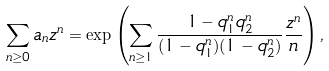<formula> <loc_0><loc_0><loc_500><loc_500>\sum _ { n \geq 0 } a _ { n } z ^ { n } = \exp \left ( \sum _ { n \geq 1 } \frac { 1 - q _ { 1 } ^ { n } q _ { 2 } ^ { n } } { ( 1 - q _ { 1 } ^ { n } ) ( 1 - q _ { 2 } ^ { n } ) } \frac { z ^ { n } } { n } \right ) ,</formula> 